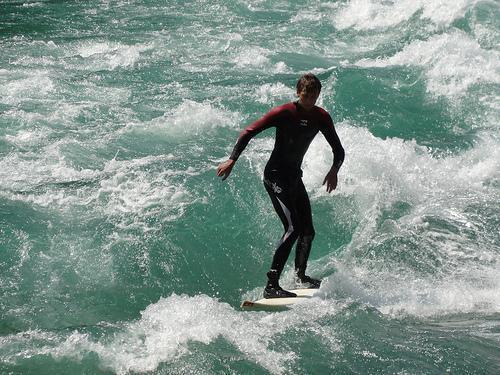How many people are there?
Give a very brief answer. 1. 